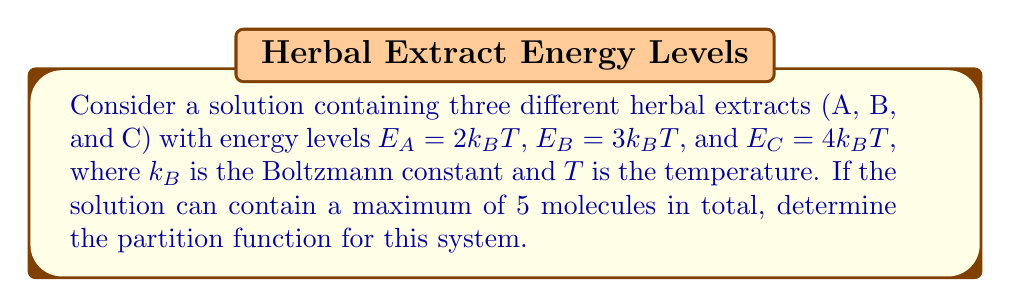Could you help me with this problem? To solve this problem, we'll follow these steps:

1) The partition function $Z$ for a system with multiple energy levels is given by:

   $$Z = \sum_i g_i e^{-\beta E_i}$$

   where $g_i$ is the degeneracy of energy level $E_i$, and $\beta = \frac{1}{k_BT}$.

2) In this case, we have three energy levels: $E_A = 2k_BT$, $E_B = 3k_BT$, and $E_C = 4k_BT$.

3) The system can contain a maximum of 5 molecules, so we need to consider all possible combinations:
   - 0 molecules (empty solution)
   - 1 molecule (A, B, or C)
   - 2 molecules (AA, AB, AC, BB, BC, CC)
   - 3 molecules (AAA, AAB, AAC, ABB, ABC, ACC, BBB, BBC, BCC, CCC)
   - 4 molecules (AAAA, AAAB, AAAC, AABB, AABC, AACC, ABBB, ABBC, ABCC, ACCC, BBBB, BBBC, BBCC, BCCC, CCCC)
   - 5 molecules (AAAAA, AAAAB, AAAAC, AAABB, AAABC, AAACC, AABBB, AABBC, AABCC, AACCC, ABBBB, ABBBC, ABBCC, ABCCC, ACCCC, BBBBB, BBBBC, BBBCC, BBCCC, BCCCC, CCCCC)

4) For each combination, we calculate $e^{-\beta E}$ where $E$ is the total energy of the combination.

5) Sum all these terms to get the partition function:

   $$Z = 1 + (e^{-2} + e^{-3} + e^{-4}) + (e^{-4} + e^{-5} + e^{-6} + e^{-6} + e^{-7} + e^{-8}) + ...$$

6) Continuing this process for all combinations up to 5 molecules, we get:

   $$Z = 1 + 3e^{-2} + 3e^{-3} + 3e^{-4} + 4e^{-5} + 4e^{-6} + 4e^{-7} + 5e^{-8} + 5e^{-9} + 5e^{-10} + 6e^{-11} + 6e^{-12} + 6e^{-13} + 7e^{-14} + 7e^{-15} + 7e^{-16} + 8e^{-17} + 8e^{-18} + 8e^{-19} + 9e^{-20}$$
Answer: $Z = 1 + 3e^{-2} + 3e^{-3} + 3e^{-4} + 4e^{-5} + 4e^{-6} + 4e^{-7} + 5e^{-8} + 5e^{-9} + 5e^{-10} + 6e^{-11} + 6e^{-12} + 6e^{-13} + 7e^{-14} + 7e^{-15} + 7e^{-16} + 8e^{-17} + 8e^{-18} + 8e^{-19} + 9e^{-20}$ 